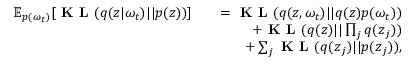<formula> <loc_0><loc_0><loc_500><loc_500>\begin{array} { r l r } { \mathbb { E } _ { p ( \omega _ { t } ) } [ K L ( q ( z | \omega _ { t } ) | | p ( z ) ) ] } & { = K L ( q ( z , \omega _ { t } ) | | q ( z ) p ( \omega _ { t } ) ) } \\ & { + K L ( q ( z ) | | \prod _ { j } q ( z _ { j } ) ) } \\ & { + \sum _ { j } K L ( q ( z _ { j } ) | | p ( z _ { j } ) ) , } \end{array}</formula> 